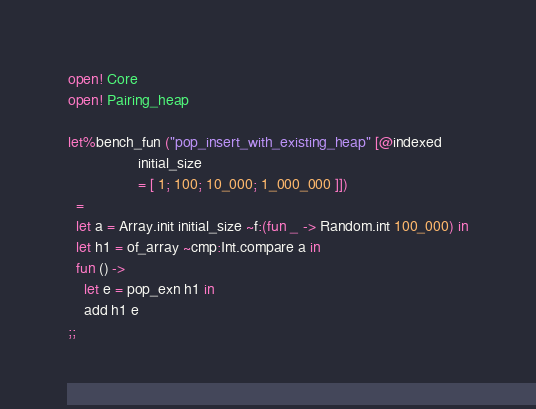Convert code to text. <code><loc_0><loc_0><loc_500><loc_500><_OCaml_>open! Core
open! Pairing_heap

let%bench_fun ("pop_insert_with_existing_heap" [@indexed
                 initial_size
                 = [ 1; 100; 10_000; 1_000_000 ]])
  =
  let a = Array.init initial_size ~f:(fun _ -> Random.int 100_000) in
  let h1 = of_array ~cmp:Int.compare a in
  fun () ->
    let e = pop_exn h1 in
    add h1 e
;;
</code> 